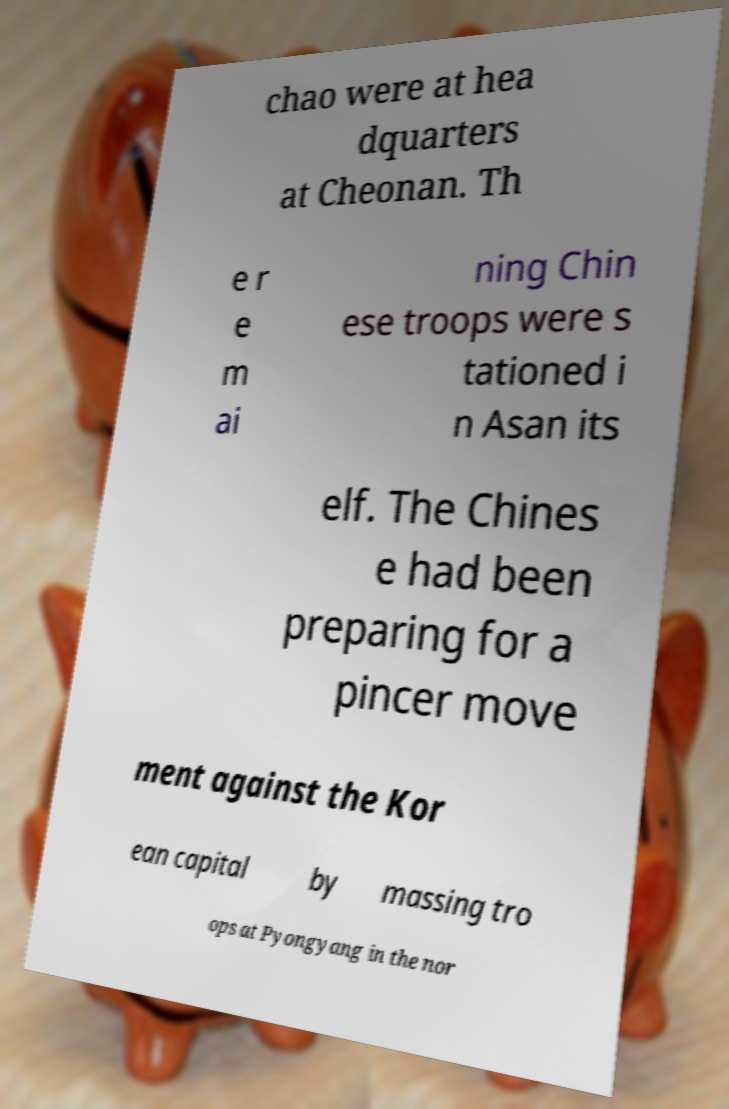Please identify and transcribe the text found in this image. chao were at hea dquarters at Cheonan. Th e r e m ai ning Chin ese troops were s tationed i n Asan its elf. The Chines e had been preparing for a pincer move ment against the Kor ean capital by massing tro ops at Pyongyang in the nor 